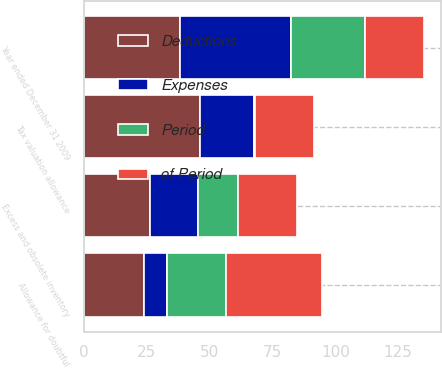Convert chart to OTSL. <chart><loc_0><loc_0><loc_500><loc_500><stacked_bar_chart><ecel><fcel>Year ended December 31 2009<fcel>Excess and obsolete inventory<fcel>Tax valuation allowance<fcel>Allowance for doubtful<nl><fcel>Deductions<fcel>38.2<fcel>26.2<fcel>46.3<fcel>23.9<nl><fcel>Period<fcel>29.5<fcel>16.2<fcel>0.5<fcel>23.4<nl><fcel>Expenses<fcel>44.22<fcel>19<fcel>21.23<fcel>9.12<nl><fcel>of Period<fcel>23.5<fcel>23.4<fcel>23.5<fcel>38.2<nl></chart> 